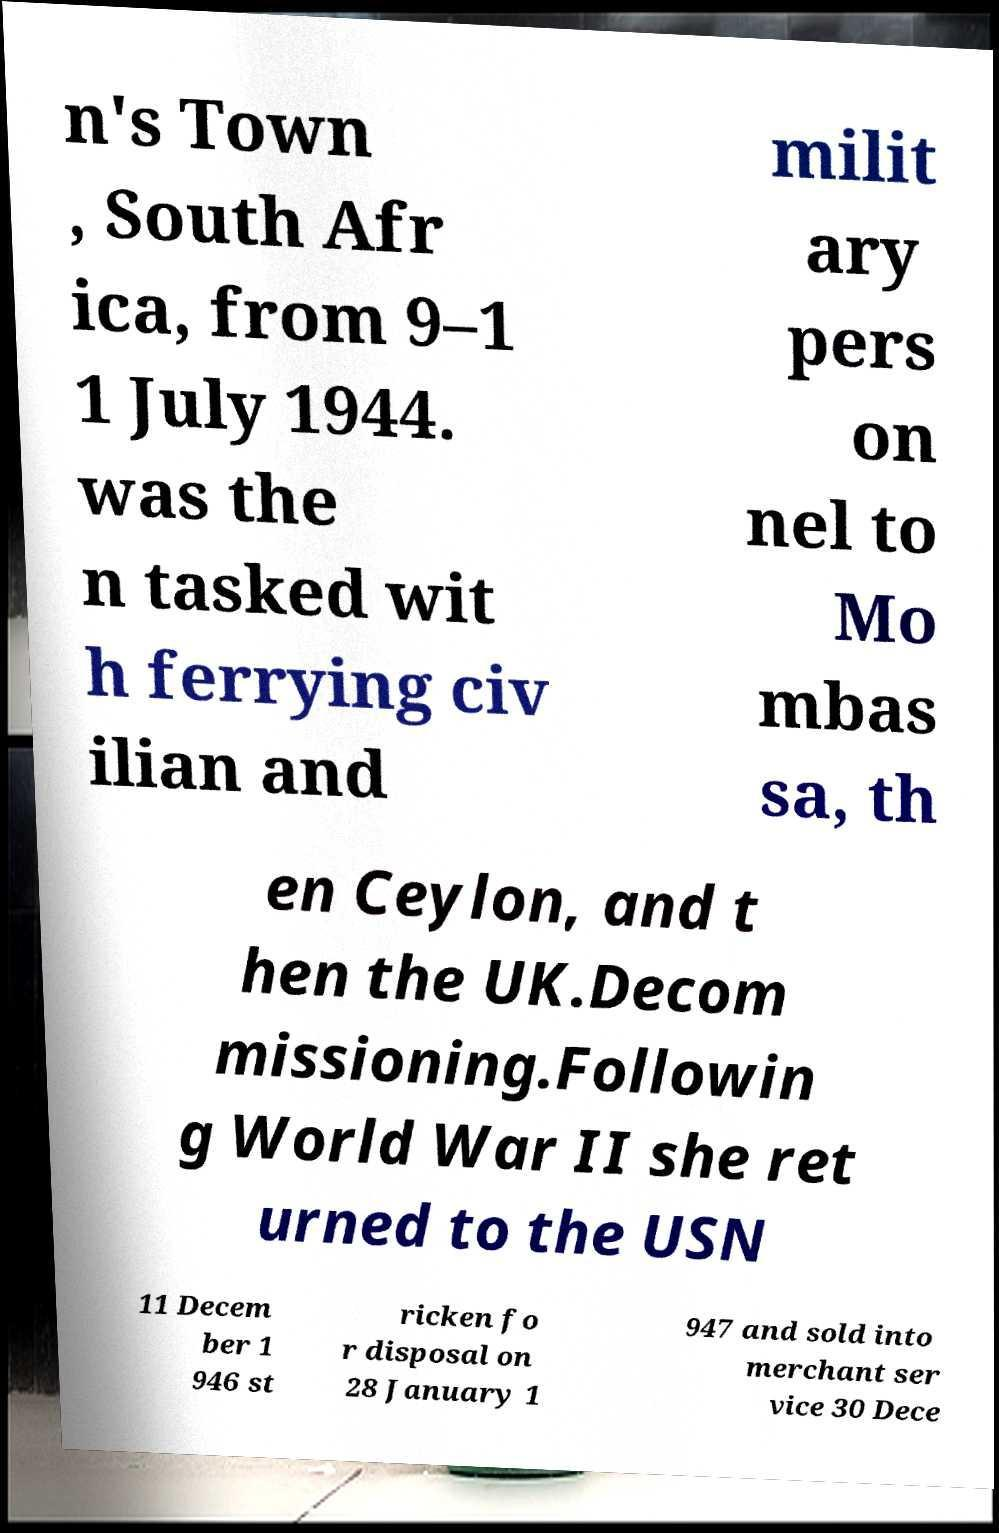Can you accurately transcribe the text from the provided image for me? n's Town , South Afr ica, from 9–1 1 July 1944. was the n tasked wit h ferrying civ ilian and milit ary pers on nel to Mo mbas sa, th en Ceylon, and t hen the UK.Decom missioning.Followin g World War II she ret urned to the USN 11 Decem ber 1 946 st ricken fo r disposal on 28 January 1 947 and sold into merchant ser vice 30 Dece 